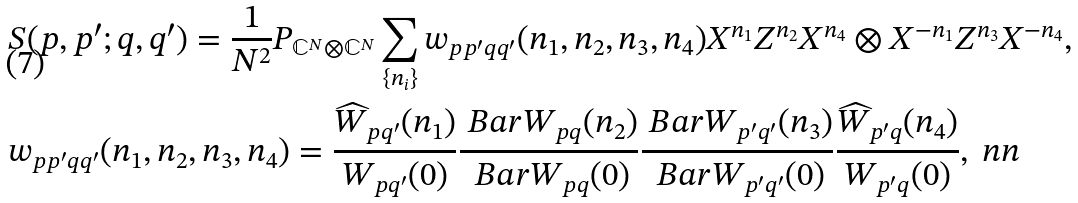<formula> <loc_0><loc_0><loc_500><loc_500>& S ( p , p ^ { \prime } ; q , q ^ { \prime } ) = \frac { 1 } { N ^ { 2 } } P _ { \mathbb { C } ^ { N } \otimes \mathbb { C } ^ { N } } \sum _ { \{ n _ { i } \} } w _ { p p ^ { \prime } q q ^ { \prime } } ( n _ { 1 } , n _ { 2 } , n _ { 3 } , n _ { 4 } ) X ^ { n _ { 1 } } Z ^ { n _ { 2 } } X ^ { n _ { 4 } } \otimes X ^ { - n _ { 1 } } Z ^ { n _ { 3 } } X ^ { - n _ { 4 } } , \\ & w _ { p p ^ { \prime } q q ^ { \prime } } ( n _ { 1 } , n _ { 2 } , n _ { 3 } , n _ { 4 } ) = \frac { \widehat { W } _ { p q ^ { \prime } } ( n _ { 1 } ) } { W _ { p q ^ { \prime } } ( 0 ) } \frac { \ B a r { W } _ { p q } ( n _ { 2 } ) } { \ B a r { W } _ { p q } ( 0 ) } \frac { \ B a r { W } _ { p ^ { \prime } q ^ { \prime } } ( n _ { 3 } ) } { \ B a r { W } _ { p ^ { \prime } q ^ { \prime } } ( 0 ) } \frac { \widehat { W } _ { p ^ { \prime } q } ( n _ { 4 } ) } { W _ { p ^ { \prime } q } ( 0 ) } , \ n n</formula> 